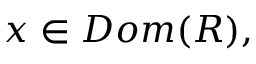<formula> <loc_0><loc_0><loc_500><loc_500>x \in D o m ( R ) ,</formula> 